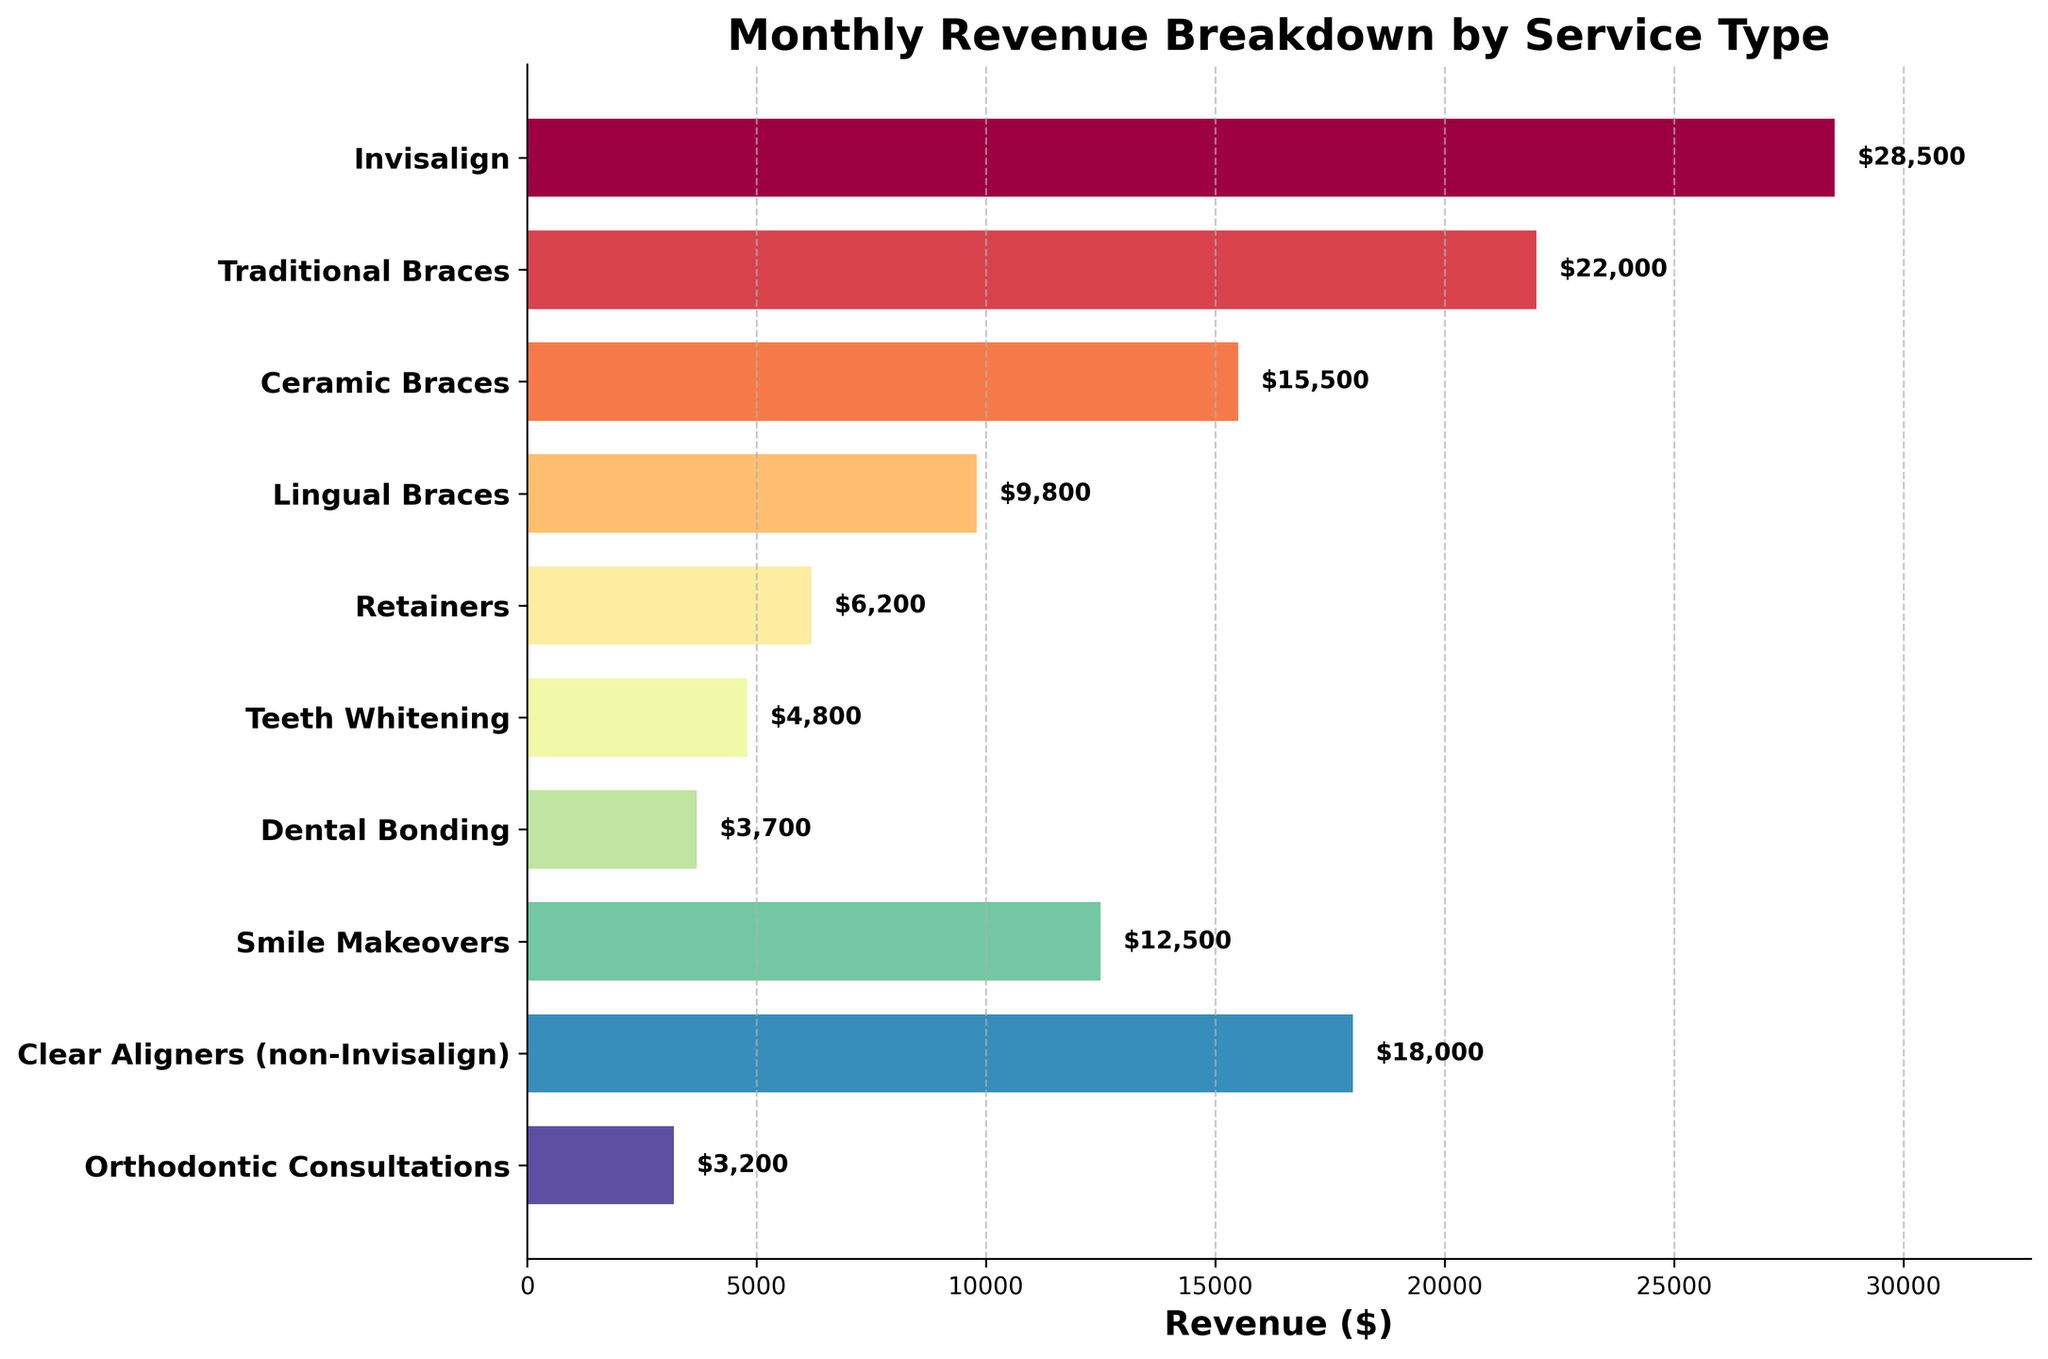What is the title of the figure? The title of the figure is usually displayed at the top of the plot. In this case, it is specifically set in the code using `ax.set_title`.
Answer: Monthly Revenue Breakdown by Service Type Which service generates the highest revenue? To find the highest revenue, look at the lengths of the horizontal bars and locate the one that is the longest. The text annotation also helps here.
Answer: Invisalign How much revenue does Teeth Whitening generate? Locate the bar labeled "Teeth Whitening" and check the text annotation or the bar length.
Answer: $4,800 What is the combined revenue of Traditional Braces and Lingual Braces? Find the revenue for each of these services: Traditional Braces ($22,000) and Lingual Braces ($9,800). Then sum them up.
Answer: $31,800 Which services generate less revenue than Smile Makeovers? Compare the lengths of the bars labeled with revenue values less than that of Smile Makeovers ($12,500).
Answer: Teeth Whitening, Retainers, Dental Bonding, Orthodontic Consultations What is the difference in revenue between Ceramic Braces and Clear Aligners (non-Invisalign)? Subtract the revenue of Ceramic Braces ($15,500) from that of Clear Aligners (non-Invisalign) ($18,000).
Answer: $2,500 Which service has the smallest revenue? Locate the shortest bar in the figure, which indicates the lowest revenue.
Answer: Orthodontic Consultations What is the average revenue generated by all services? Add up the revenue of all services and then divide by the number of services to get the average revenue. Total revenue = $126,000, Number of services = 10, so average = $126,000 / 10.
Answer: $12,600 Would you say that most services generate revenue above or below the average revenue? Compare each service’s revenue to the average revenue of $12,600. Check if the majority of the revenue amounts are above or below this average.
Answer: Below Which bar color range is used to represent the services in the figure? The colors of the bars are generated using the Spectral colormap, which generally varies from cool to warm colors.
Answer: Spectral colormap range 